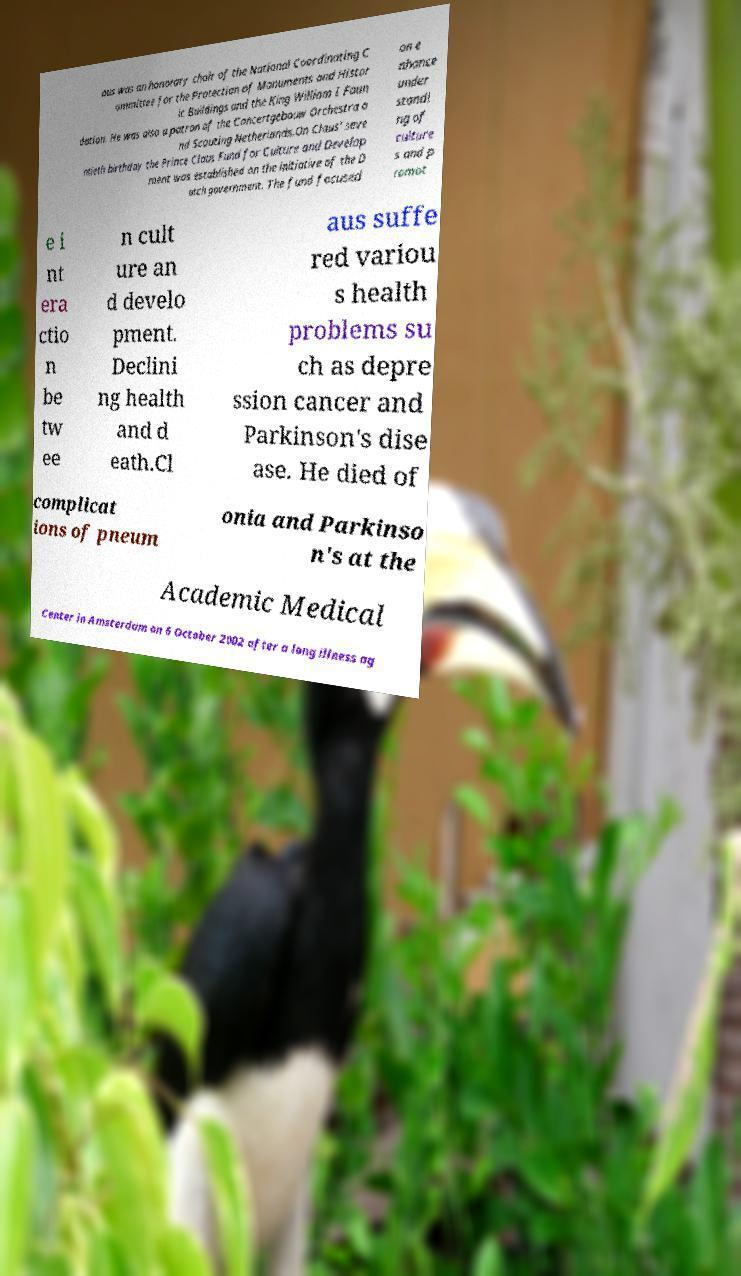Could you assist in decoding the text presented in this image and type it out clearly? aus was an honorary chair of the National Coordinating C ommittee for the Protection of Monuments and Histor ic Buildings and the King William I Foun dation. He was also a patron of the Concertgebouw Orchestra a nd Scouting Netherlands.On Claus' seve ntieth birthday the Prince Claus Fund for Culture and Develop ment was established on the initiative of the D utch government. The fund focused on e nhance under standi ng of culture s and p romot e i nt era ctio n be tw ee n cult ure an d develo pment. Declini ng health and d eath.Cl aus suffe red variou s health problems su ch as depre ssion cancer and Parkinson's dise ase. He died of complicat ions of pneum onia and Parkinso n's at the Academic Medical Center in Amsterdam on 6 October 2002 after a long illness ag 